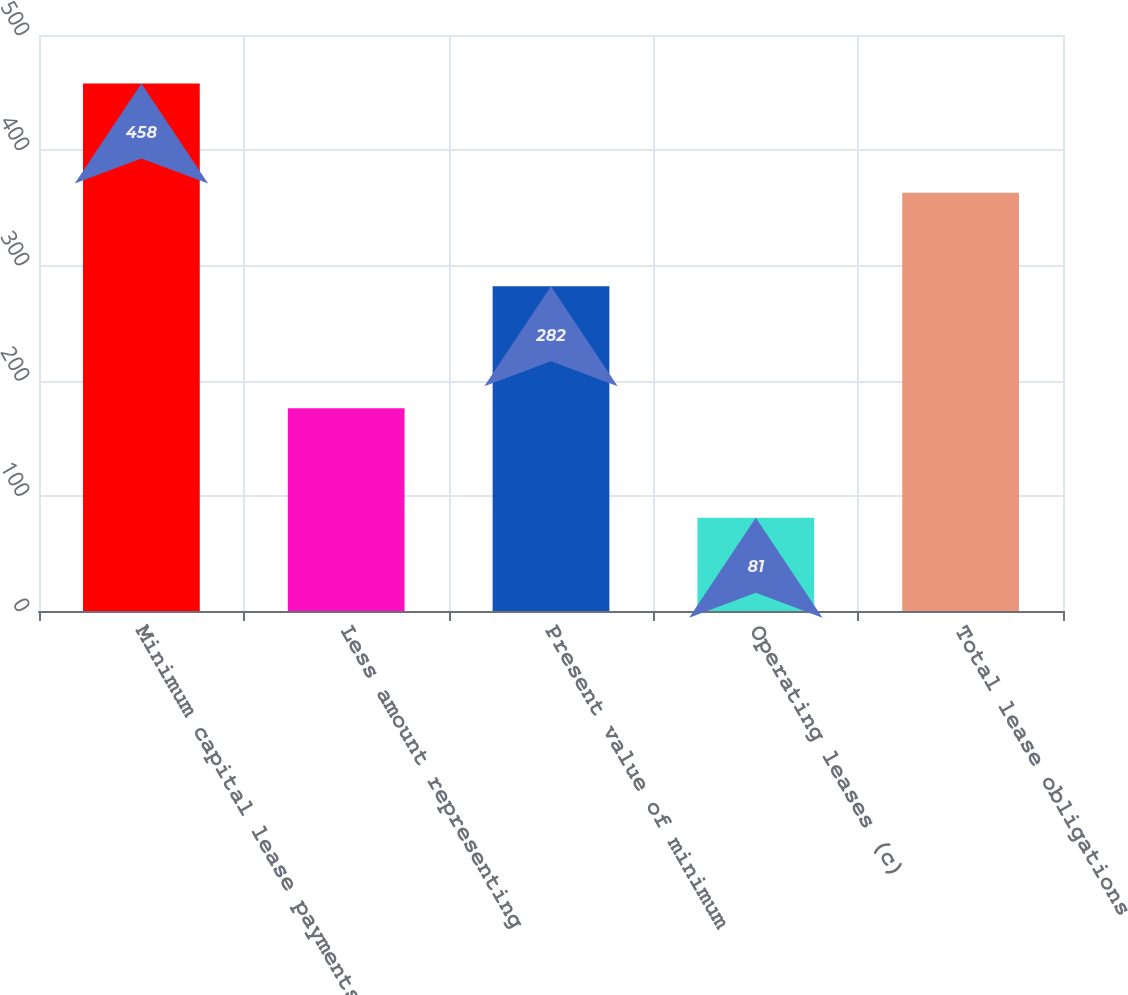Convert chart. <chart><loc_0><loc_0><loc_500><loc_500><bar_chart><fcel>Minimum capital lease payments<fcel>Less amount representing<fcel>Present value of minimum<fcel>Operating leases (c)<fcel>Total lease obligations<nl><fcel>458<fcel>176<fcel>282<fcel>81<fcel>363<nl></chart> 